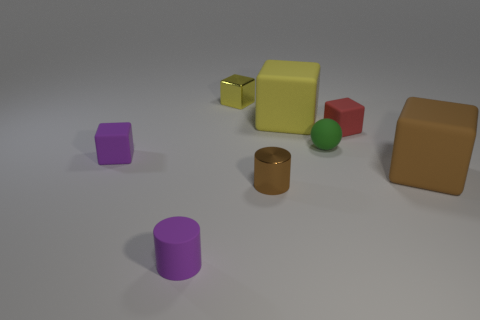Subtract 2 blocks. How many blocks are left? 3 Subtract all metal blocks. How many blocks are left? 4 Subtract all red blocks. How many blocks are left? 4 Subtract all cyan blocks. Subtract all gray cylinders. How many blocks are left? 5 Add 1 purple rubber cylinders. How many objects exist? 9 Subtract all cylinders. How many objects are left? 6 Subtract all yellow objects. Subtract all big brown cubes. How many objects are left? 5 Add 1 tiny brown metallic cylinders. How many tiny brown metallic cylinders are left? 2 Add 4 big green cylinders. How many big green cylinders exist? 4 Subtract 1 yellow blocks. How many objects are left? 7 